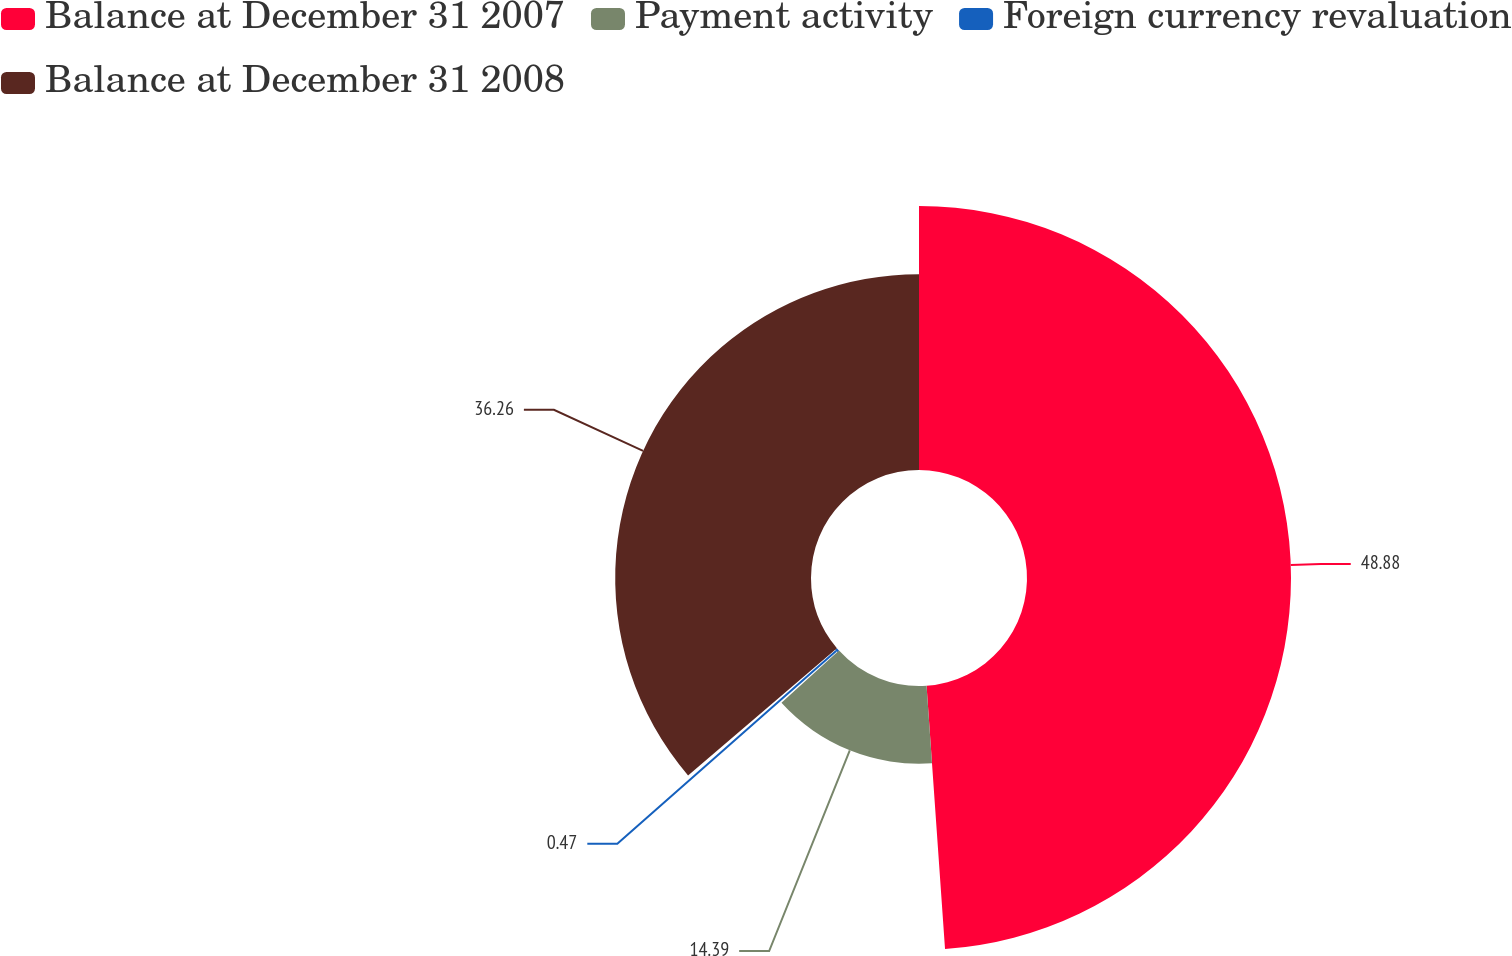Convert chart to OTSL. <chart><loc_0><loc_0><loc_500><loc_500><pie_chart><fcel>Balance at December 31 2007<fcel>Payment activity<fcel>Foreign currency revaluation<fcel>Balance at December 31 2008<nl><fcel>48.89%<fcel>14.39%<fcel>0.47%<fcel>36.26%<nl></chart> 